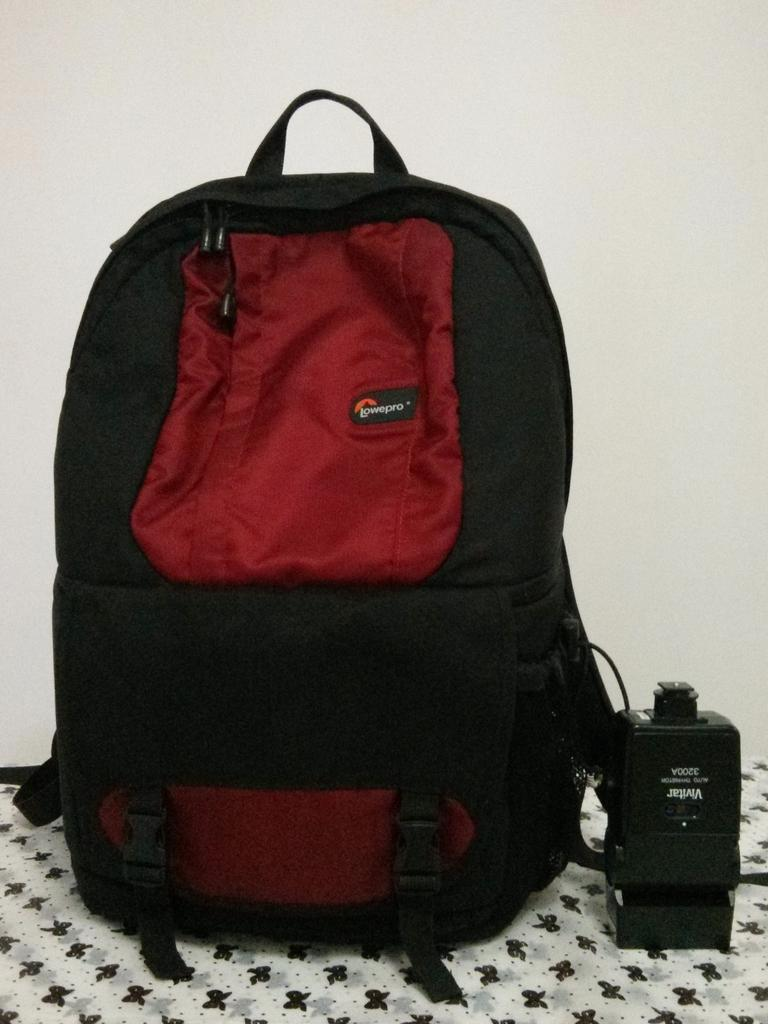What colors are the bags on the table? There is a red bag and a black bag on the table. What is the material of the cloth on the table? The cloth on the table is a design cloth. Can you describe any other items on the table besides the bags and cloth? There is at least one other item on the table. What type of egg is being sorted by your dad in the image? There is no egg or dad present in the image. 